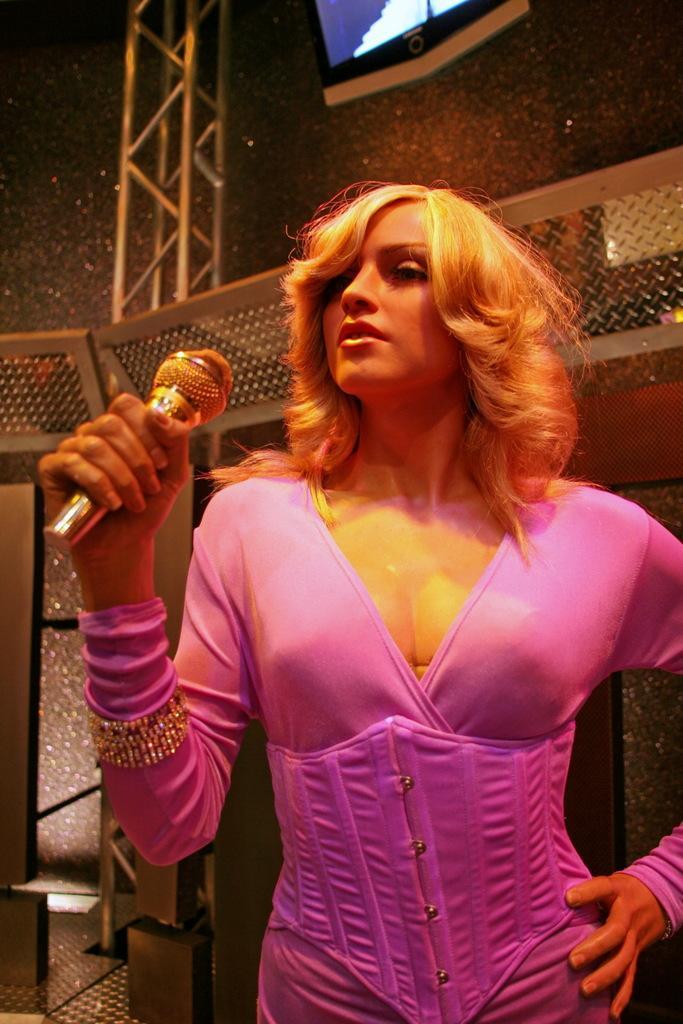Please provide a concise description of this image. In this image i can see a woman standing and holding microphone at the back ground i can see a railing. 